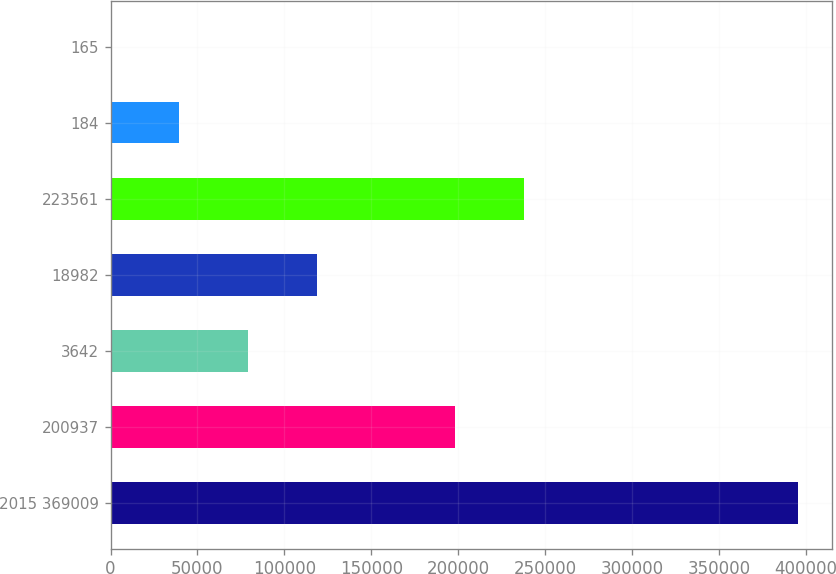Convert chart. <chart><loc_0><loc_0><loc_500><loc_500><bar_chart><fcel>2015 369009<fcel>200937<fcel>3642<fcel>18982<fcel>223561<fcel>184<fcel>165<nl><fcel>395281<fcel>198291<fcel>79057.7<fcel>118586<fcel>237819<fcel>39529.7<fcel>1.82<nl></chart> 